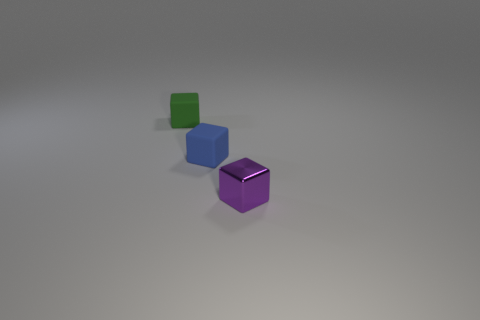Add 1 small blue rubber blocks. How many objects exist? 4 Subtract all blue blocks. How many blocks are left? 2 Subtract 1 blocks. How many blocks are left? 2 Subtract all purple cubes. How many cubes are left? 2 Subtract 0 purple spheres. How many objects are left? 3 Subtract all cyan blocks. Subtract all cyan balls. How many blocks are left? 3 Subtract all small purple blocks. Subtract all small purple objects. How many objects are left? 1 Add 1 shiny blocks. How many shiny blocks are left? 2 Add 1 tiny blue things. How many tiny blue things exist? 2 